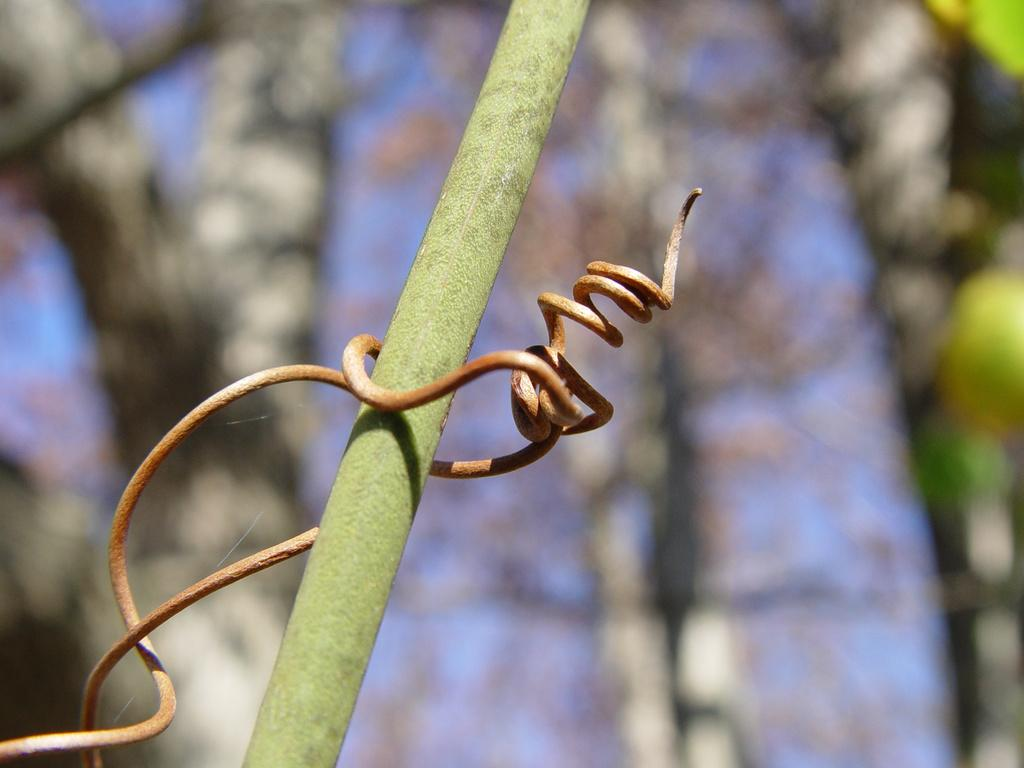What is the main object in the image? There is a pole in the image. What is attached to the pole? The pole has a metal wire attached to it. What story is being told by the finger in the image? There is no finger present in the image, so no story can be told by it. 